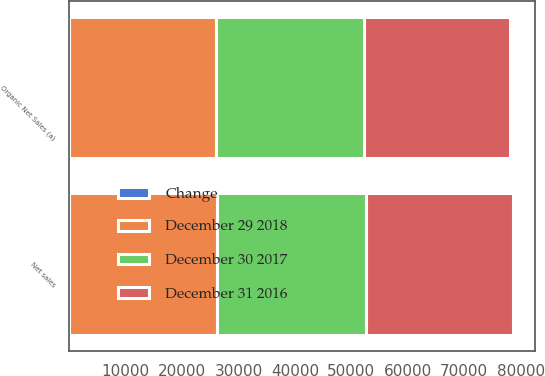Convert chart. <chart><loc_0><loc_0><loc_500><loc_500><stacked_bar_chart><ecel><fcel>Net sales<fcel>Organic Net Sales (a)<nl><fcel>December 29 2018<fcel>26268<fcel>26105<nl><fcel>December 31 2016<fcel>26076<fcel>25876<nl><fcel>Change<fcel>0.7<fcel>0.9<nl><fcel>December 30 2017<fcel>26300<fcel>26188<nl></chart> 